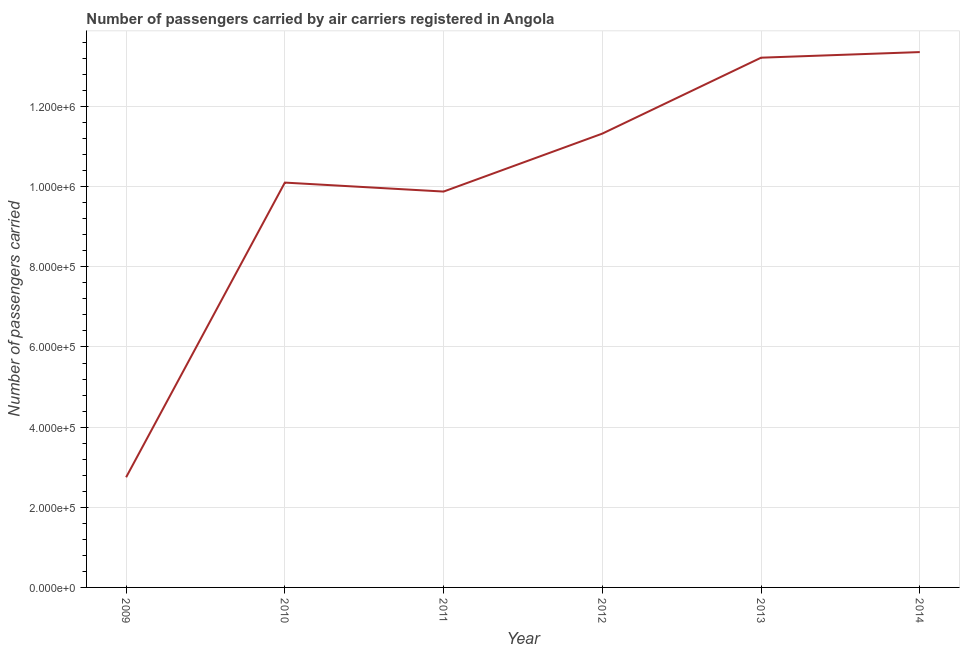What is the number of passengers carried in 2010?
Your response must be concise. 1.01e+06. Across all years, what is the maximum number of passengers carried?
Offer a terse response. 1.34e+06. Across all years, what is the minimum number of passengers carried?
Make the answer very short. 2.75e+05. In which year was the number of passengers carried minimum?
Offer a terse response. 2009. What is the sum of the number of passengers carried?
Your answer should be very brief. 6.06e+06. What is the difference between the number of passengers carried in 2013 and 2014?
Ensure brevity in your answer.  -1.40e+04. What is the average number of passengers carried per year?
Your answer should be compact. 1.01e+06. What is the median number of passengers carried?
Your answer should be very brief. 1.07e+06. In how many years, is the number of passengers carried greater than 1240000 ?
Ensure brevity in your answer.  2. What is the ratio of the number of passengers carried in 2009 to that in 2011?
Your answer should be very brief. 0.28. What is the difference between the highest and the second highest number of passengers carried?
Offer a terse response. 1.40e+04. What is the difference between the highest and the lowest number of passengers carried?
Offer a terse response. 1.06e+06. How many years are there in the graph?
Keep it short and to the point. 6. What is the difference between two consecutive major ticks on the Y-axis?
Ensure brevity in your answer.  2.00e+05. Are the values on the major ticks of Y-axis written in scientific E-notation?
Offer a terse response. Yes. Does the graph contain any zero values?
Your answer should be compact. No. Does the graph contain grids?
Offer a very short reply. Yes. What is the title of the graph?
Offer a terse response. Number of passengers carried by air carriers registered in Angola. What is the label or title of the X-axis?
Provide a succinct answer. Year. What is the label or title of the Y-axis?
Your response must be concise. Number of passengers carried. What is the Number of passengers carried in 2009?
Offer a very short reply. 2.75e+05. What is the Number of passengers carried in 2010?
Provide a succinct answer. 1.01e+06. What is the Number of passengers carried in 2011?
Give a very brief answer. 9.88e+05. What is the Number of passengers carried in 2012?
Your answer should be compact. 1.13e+06. What is the Number of passengers carried in 2013?
Ensure brevity in your answer.  1.32e+06. What is the Number of passengers carried of 2014?
Give a very brief answer. 1.34e+06. What is the difference between the Number of passengers carried in 2009 and 2010?
Offer a very short reply. -7.35e+05. What is the difference between the Number of passengers carried in 2009 and 2011?
Your answer should be compact. -7.13e+05. What is the difference between the Number of passengers carried in 2009 and 2012?
Your answer should be compact. -8.58e+05. What is the difference between the Number of passengers carried in 2009 and 2013?
Offer a terse response. -1.05e+06. What is the difference between the Number of passengers carried in 2009 and 2014?
Your response must be concise. -1.06e+06. What is the difference between the Number of passengers carried in 2010 and 2011?
Your answer should be compact. 2.24e+04. What is the difference between the Number of passengers carried in 2010 and 2012?
Make the answer very short. -1.22e+05. What is the difference between the Number of passengers carried in 2010 and 2013?
Provide a succinct answer. -3.12e+05. What is the difference between the Number of passengers carried in 2010 and 2014?
Provide a short and direct response. -3.26e+05. What is the difference between the Number of passengers carried in 2011 and 2012?
Make the answer very short. -1.45e+05. What is the difference between the Number of passengers carried in 2011 and 2013?
Provide a short and direct response. -3.34e+05. What is the difference between the Number of passengers carried in 2011 and 2014?
Give a very brief answer. -3.48e+05. What is the difference between the Number of passengers carried in 2012 and 2013?
Give a very brief answer. -1.89e+05. What is the difference between the Number of passengers carried in 2012 and 2014?
Make the answer very short. -2.03e+05. What is the difference between the Number of passengers carried in 2013 and 2014?
Make the answer very short. -1.40e+04. What is the ratio of the Number of passengers carried in 2009 to that in 2010?
Offer a very short reply. 0.27. What is the ratio of the Number of passengers carried in 2009 to that in 2011?
Provide a succinct answer. 0.28. What is the ratio of the Number of passengers carried in 2009 to that in 2012?
Ensure brevity in your answer.  0.24. What is the ratio of the Number of passengers carried in 2009 to that in 2013?
Ensure brevity in your answer.  0.21. What is the ratio of the Number of passengers carried in 2009 to that in 2014?
Your answer should be compact. 0.21. What is the ratio of the Number of passengers carried in 2010 to that in 2012?
Your answer should be very brief. 0.89. What is the ratio of the Number of passengers carried in 2010 to that in 2013?
Provide a short and direct response. 0.76. What is the ratio of the Number of passengers carried in 2010 to that in 2014?
Keep it short and to the point. 0.76. What is the ratio of the Number of passengers carried in 2011 to that in 2012?
Offer a very short reply. 0.87. What is the ratio of the Number of passengers carried in 2011 to that in 2013?
Offer a very short reply. 0.75. What is the ratio of the Number of passengers carried in 2011 to that in 2014?
Make the answer very short. 0.74. What is the ratio of the Number of passengers carried in 2012 to that in 2013?
Make the answer very short. 0.86. What is the ratio of the Number of passengers carried in 2012 to that in 2014?
Your answer should be compact. 0.85. 